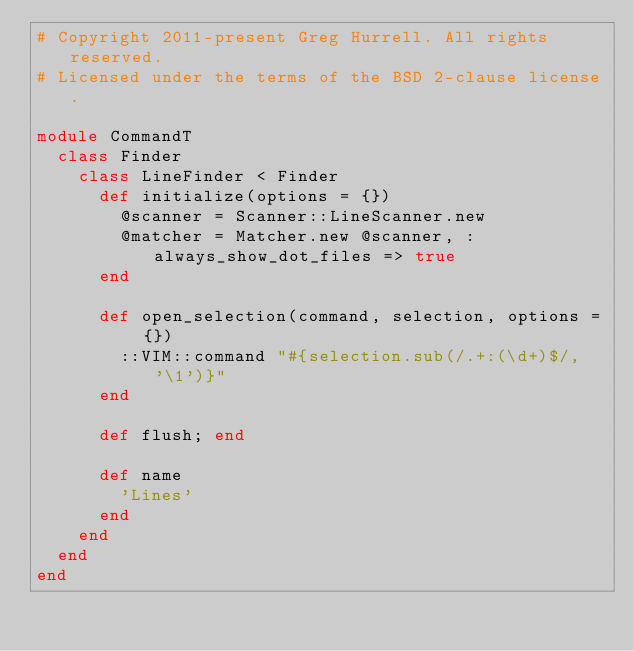Convert code to text. <code><loc_0><loc_0><loc_500><loc_500><_Ruby_># Copyright 2011-present Greg Hurrell. All rights reserved.
# Licensed under the terms of the BSD 2-clause license.

module CommandT
  class Finder
    class LineFinder < Finder
      def initialize(options = {})
        @scanner = Scanner::LineScanner.new
        @matcher = Matcher.new @scanner, :always_show_dot_files => true
      end

      def open_selection(command, selection, options = {})
        ::VIM::command "#{selection.sub(/.+:(\d+)$/, '\1')}"
      end

      def flush; end

      def name
        'Lines'
      end
    end
  end
end
</code> 